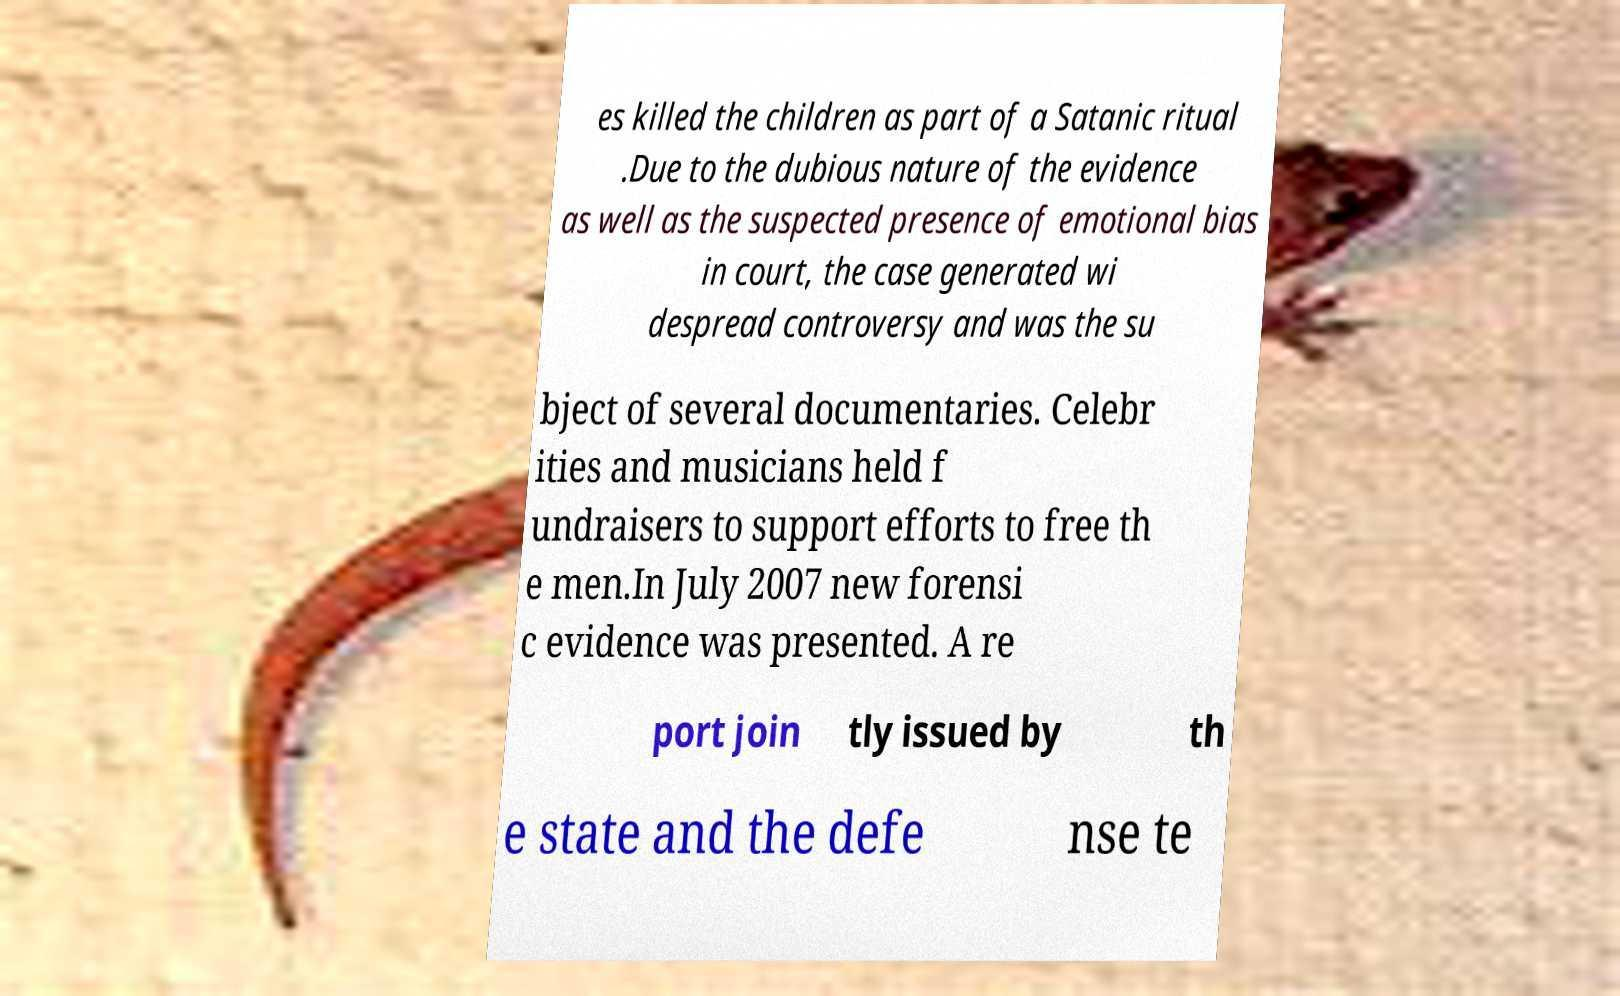Can you read and provide the text displayed in the image?This photo seems to have some interesting text. Can you extract and type it out for me? es killed the children as part of a Satanic ritual .Due to the dubious nature of the evidence as well as the suspected presence of emotional bias in court, the case generated wi despread controversy and was the su bject of several documentaries. Celebr ities and musicians held f undraisers to support efforts to free th e men.In July 2007 new forensi c evidence was presented. A re port join tly issued by th e state and the defe nse te 